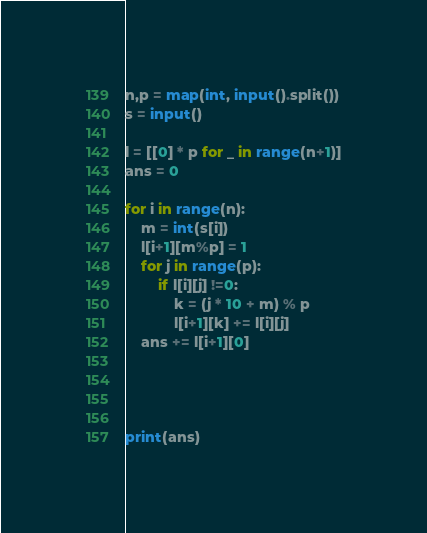<code> <loc_0><loc_0><loc_500><loc_500><_Python_>n,p = map(int, input().split())
s = input()

l = [[0] * p for _ in range(n+1)]
ans = 0

for i in range(n):
    m = int(s[i])
    l[i+1][m%p] = 1
    for j in range(p):
        if l[i][j] !=0:
            k = (j * 10 + m) % p
            l[i+1][k] += l[i][j]
    ans += l[i+1][0]




print(ans)</code> 